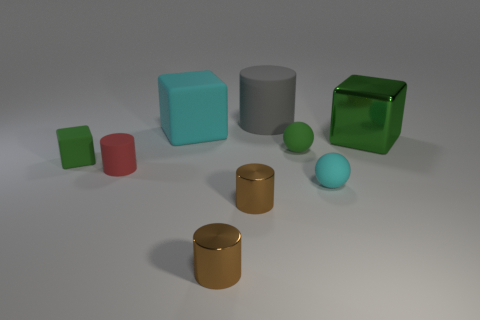What shape is the large gray matte object on the left side of the large green object?
Offer a very short reply. Cylinder. What size is the green sphere that is the same material as the red thing?
Your answer should be compact. Small. The thing that is behind the green sphere and right of the gray rubber cylinder has what shape?
Offer a terse response. Cube. There is a tiny rubber sphere that is to the right of the small green sphere; is it the same color as the metallic cube?
Provide a short and direct response. No. There is a cyan matte thing that is behind the large metal thing; does it have the same shape as the shiny thing on the right side of the tiny cyan rubber object?
Offer a very short reply. Yes. How big is the shiny object to the right of the small green rubber sphere?
Provide a succinct answer. Large. There is a rubber cylinder that is left of the matte thing behind the big cyan cube; what is its size?
Ensure brevity in your answer.  Small. Are there more tiny green matte objects than red metal things?
Provide a short and direct response. Yes. Is the number of big cyan blocks to the left of the tiny red cylinder greater than the number of large cyan matte cubes on the right side of the big cyan matte object?
Your answer should be very brief. No. There is a cylinder that is right of the red matte thing and behind the small cyan object; how big is it?
Keep it short and to the point. Large. 